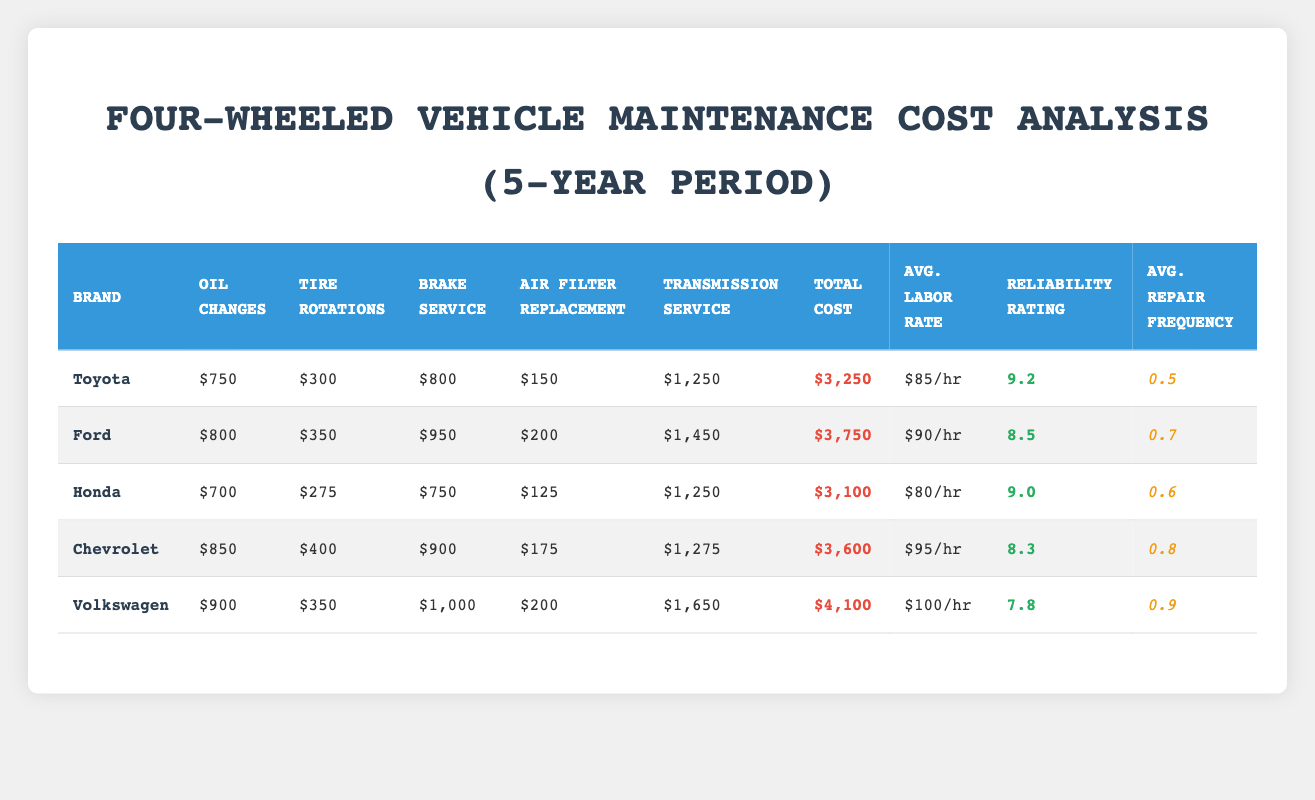What is the total maintenance cost for Honda over the 5-year period? The table shows that the total cost for Honda is listed under the "Total Cost" column. For Honda, this value is $3,100.
Answer: $3,100 Which vehicle brand has the highest average labor rate? The average labor rates for each brand are as follows: Toyota at $85/hr, Ford at $90/hr, Honda at $80/hr, Chevrolet at $95/hr, and Volkswagen at $100/hr. VW has the highest at $100/hr.
Answer: Volkswagen What is the difference in total maintenance costs between the cheapest and the most expensive vehicle brands? The total maintenance cost for Toyota is $3,250 (the cheapest) and for Volkswagen is $4,100 (the most expensive). The difference is calculated as $4,100 - $3,250 = $850.
Answer: $850 Is the reliability rating of Ford greater than that of Chevrolet? Ford has a reliability rating of 8.5, while Chevrolet has a rating of 8.3. Since 8.5 is greater than 8.3, the answer is true.
Answer: Yes What is the total cost of oil changes for all vehicle brands combined? To find the total for oil changes, sum the values in the "Oil Changes" column: $750 (Toyota) + $800 (Ford) + $700 (Honda) + $850 (Chevrolet) + $900 (Volkswagen) = $4,000.
Answer: $4,000 Which brand has the lowest average repair frequency? The average repair frequency for each brand is as follows: Toyota 0.5, Ford 0.7, Honda 0.6, Chevrolet 0.8, and Volkswagen 0.9. Toyota has the lowest frequency at 0.5.
Answer: Toyota Calculate the total maintenance cost for brakes across all vehicle brands. The total cost for brake services is calculated by summing the values in the "Brake Service" column: $800 (Toyota) + $950 (Ford) + $750 (Honda) + $900 (Chevrolet) + $1,000 (Volkswagen) = $3,400.
Answer: $3,400 Which vehicle brand has both the highest total cost and the lowest reliability rating? Comparing total costs, Volkswagen ($4,100) has the highest, and its reliability rating is 7.8, which is the lowest among the brands listed.
Answer: Volkswagen Is the average labor rate for Honda lower than that of Toyota? Honda's average labor rate is $80/hr, while Toyota's is $85/hr. Since $80 is less than $85, the answer is true.
Answer: Yes 